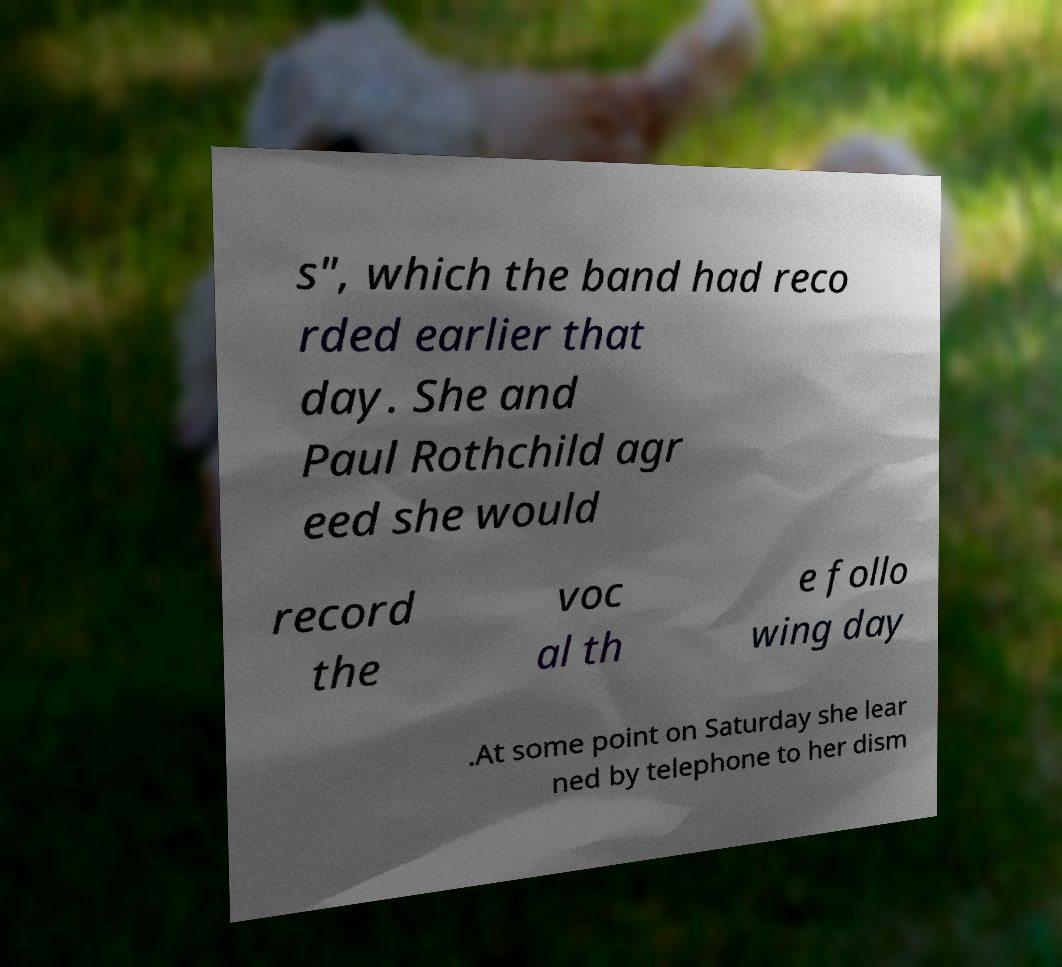I need the written content from this picture converted into text. Can you do that? s", which the band had reco rded earlier that day. She and Paul Rothchild agr eed she would record the voc al th e follo wing day .At some point on Saturday she lear ned by telephone to her dism 